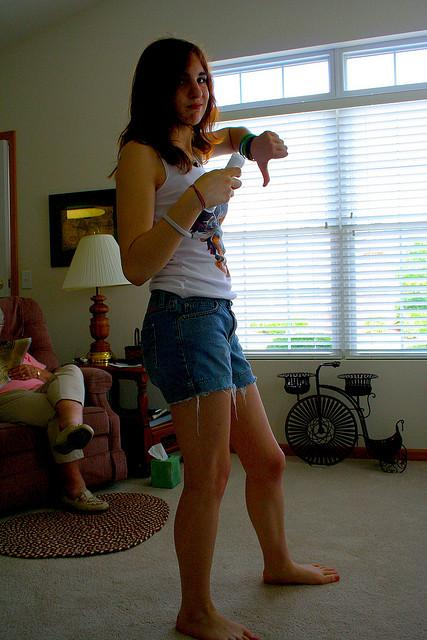What is the window covering called? blinds 